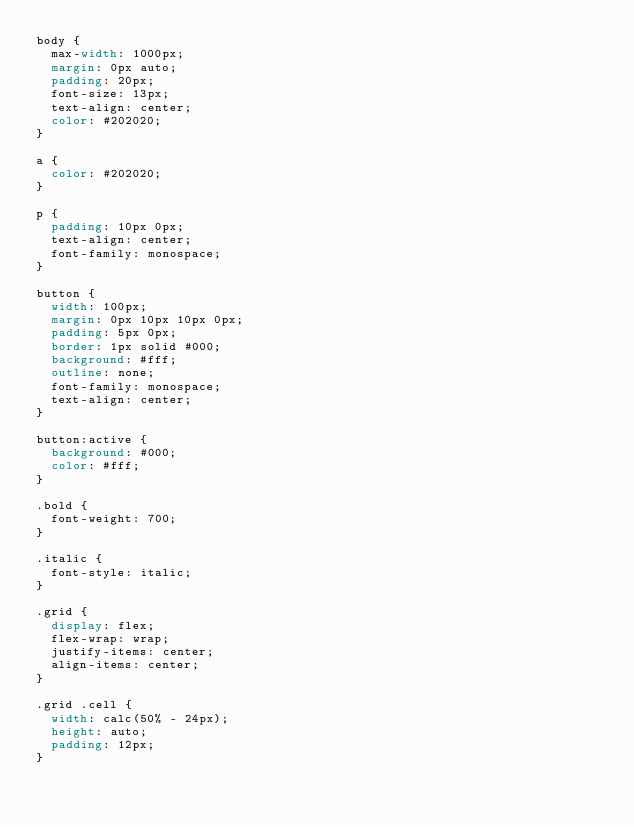<code> <loc_0><loc_0><loc_500><loc_500><_CSS_>body {
  max-width: 1000px;
  margin: 0px auto;
  padding: 20px;
  font-size: 13px;
  text-align: center;
  color: #202020;
}

a {
  color: #202020;
}

p {
  padding: 10px 0px;
  text-align: center;
  font-family: monospace;
}

button {
  width: 100px;
  margin: 0px 10px 10px 0px;
  padding: 5px 0px;
  border: 1px solid #000;
  background: #fff;
  outline: none;
  font-family: monospace;
  text-align: center;
}

button:active {
  background: #000;
  color: #fff;
}

.bold {
  font-weight: 700;
}

.italic {
  font-style: italic;
}

.grid {
  display: flex;
  flex-wrap: wrap;
  justify-items: center;
  align-items: center;
}

.grid .cell {
  width: calc(50% - 24px);
  height: auto;
  padding: 12px;
}
</code> 